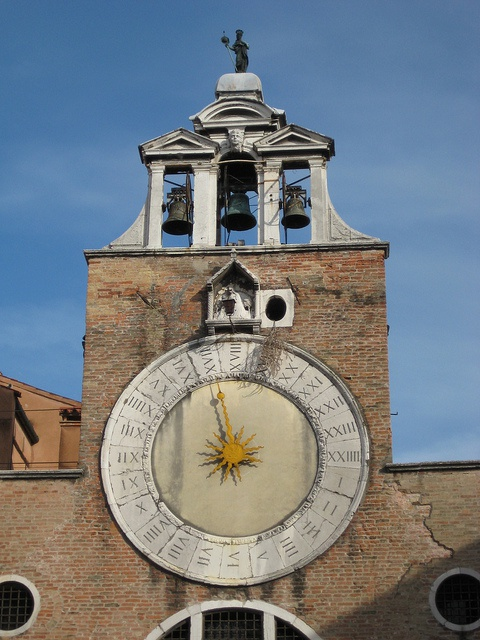Describe the objects in this image and their specific colors. I can see a clock in gray, darkgray, and lightgray tones in this image. 